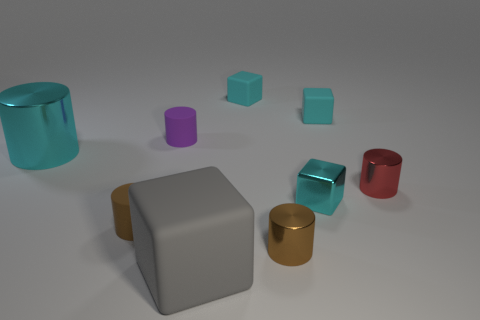How does the lighting in the image affect the appearance of the objects? The lighting in the image is soft and diffused, casting gentle shadows that define the shapes of the objects without creating harsh lines. It enhances the reflective properties of the shiny objects, allowing them to stand out, while giving the matte surfaces a subdued appearance. 